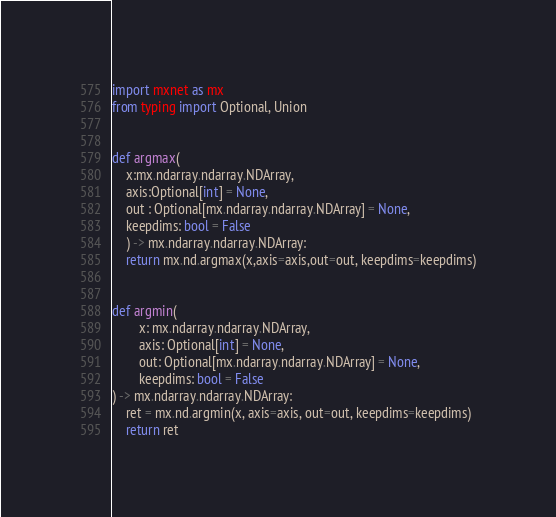Convert code to text. <code><loc_0><loc_0><loc_500><loc_500><_Python_>import mxnet as mx
from typing import Optional, Union


def argmax(
    x:mx.ndarray.ndarray.NDArray,
    axis:Optional[int] = None, 
    out : Optional[mx.ndarray.ndarray.NDArray] = None,
    keepdims: bool = False
    ) -> mx.ndarray.ndarray.NDArray:
    return mx.nd.argmax(x,axis=axis,out=out, keepdims=keepdims)


def argmin(
        x: mx.ndarray.ndarray.NDArray,
        axis: Optional[int] = None,
        out: Optional[mx.ndarray.ndarray.NDArray] = None,
        keepdims: bool = False
) -> mx.ndarray.ndarray.NDArray:
    ret = mx.nd.argmin(x, axis=axis, out=out, keepdims=keepdims)
    return ret
</code> 